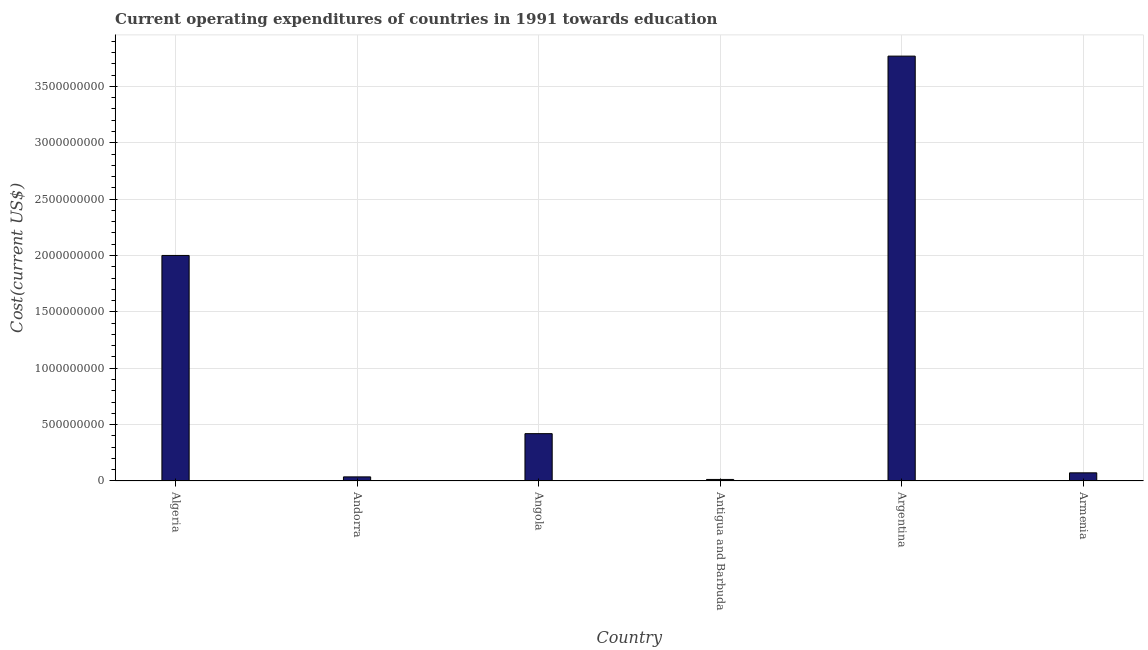What is the title of the graph?
Your answer should be very brief. Current operating expenditures of countries in 1991 towards education. What is the label or title of the Y-axis?
Ensure brevity in your answer.  Cost(current US$). What is the education expenditure in Antigua and Barbuda?
Give a very brief answer. 1.37e+07. Across all countries, what is the maximum education expenditure?
Make the answer very short. 3.77e+09. Across all countries, what is the minimum education expenditure?
Your answer should be very brief. 1.37e+07. In which country was the education expenditure minimum?
Keep it short and to the point. Antigua and Barbuda. What is the sum of the education expenditure?
Offer a very short reply. 6.31e+09. What is the difference between the education expenditure in Algeria and Antigua and Barbuda?
Ensure brevity in your answer.  1.99e+09. What is the average education expenditure per country?
Your response must be concise. 1.05e+09. What is the median education expenditure?
Provide a short and direct response. 2.46e+08. What is the ratio of the education expenditure in Andorra to that in Armenia?
Keep it short and to the point. 0.51. What is the difference between the highest and the second highest education expenditure?
Make the answer very short. 1.77e+09. What is the difference between the highest and the lowest education expenditure?
Offer a very short reply. 3.76e+09. In how many countries, is the education expenditure greater than the average education expenditure taken over all countries?
Offer a very short reply. 2. How many bars are there?
Your answer should be compact. 6. What is the difference between two consecutive major ticks on the Y-axis?
Keep it short and to the point. 5.00e+08. Are the values on the major ticks of Y-axis written in scientific E-notation?
Provide a succinct answer. No. What is the Cost(current US$) of Algeria?
Provide a short and direct response. 2.00e+09. What is the Cost(current US$) in Andorra?
Provide a short and direct response. 3.65e+07. What is the Cost(current US$) of Angola?
Your answer should be very brief. 4.20e+08. What is the Cost(current US$) in Antigua and Barbuda?
Your answer should be very brief. 1.37e+07. What is the Cost(current US$) in Argentina?
Offer a terse response. 3.77e+09. What is the Cost(current US$) in Armenia?
Provide a short and direct response. 7.23e+07. What is the difference between the Cost(current US$) in Algeria and Andorra?
Provide a succinct answer. 1.96e+09. What is the difference between the Cost(current US$) in Algeria and Angola?
Ensure brevity in your answer.  1.58e+09. What is the difference between the Cost(current US$) in Algeria and Antigua and Barbuda?
Provide a succinct answer. 1.99e+09. What is the difference between the Cost(current US$) in Algeria and Argentina?
Offer a very short reply. -1.77e+09. What is the difference between the Cost(current US$) in Algeria and Armenia?
Offer a terse response. 1.93e+09. What is the difference between the Cost(current US$) in Andorra and Angola?
Your answer should be compact. -3.83e+08. What is the difference between the Cost(current US$) in Andorra and Antigua and Barbuda?
Give a very brief answer. 2.28e+07. What is the difference between the Cost(current US$) in Andorra and Argentina?
Your answer should be very brief. -3.73e+09. What is the difference between the Cost(current US$) in Andorra and Armenia?
Your answer should be compact. -3.58e+07. What is the difference between the Cost(current US$) in Angola and Antigua and Barbuda?
Keep it short and to the point. 4.06e+08. What is the difference between the Cost(current US$) in Angola and Argentina?
Offer a very short reply. -3.35e+09. What is the difference between the Cost(current US$) in Angola and Armenia?
Give a very brief answer. 3.48e+08. What is the difference between the Cost(current US$) in Antigua and Barbuda and Argentina?
Your answer should be very brief. -3.76e+09. What is the difference between the Cost(current US$) in Antigua and Barbuda and Armenia?
Keep it short and to the point. -5.86e+07. What is the difference between the Cost(current US$) in Argentina and Armenia?
Ensure brevity in your answer.  3.70e+09. What is the ratio of the Cost(current US$) in Algeria to that in Andorra?
Your answer should be compact. 54.77. What is the ratio of the Cost(current US$) in Algeria to that in Angola?
Provide a short and direct response. 4.76. What is the ratio of the Cost(current US$) in Algeria to that in Antigua and Barbuda?
Your answer should be compact. 146.26. What is the ratio of the Cost(current US$) in Algeria to that in Argentina?
Offer a very short reply. 0.53. What is the ratio of the Cost(current US$) in Algeria to that in Armenia?
Keep it short and to the point. 27.67. What is the ratio of the Cost(current US$) in Andorra to that in Angola?
Ensure brevity in your answer.  0.09. What is the ratio of the Cost(current US$) in Andorra to that in Antigua and Barbuda?
Your answer should be compact. 2.67. What is the ratio of the Cost(current US$) in Andorra to that in Argentina?
Provide a short and direct response. 0.01. What is the ratio of the Cost(current US$) in Andorra to that in Armenia?
Provide a succinct answer. 0.51. What is the ratio of the Cost(current US$) in Angola to that in Antigua and Barbuda?
Give a very brief answer. 30.7. What is the ratio of the Cost(current US$) in Angola to that in Argentina?
Your response must be concise. 0.11. What is the ratio of the Cost(current US$) in Angola to that in Armenia?
Ensure brevity in your answer.  5.81. What is the ratio of the Cost(current US$) in Antigua and Barbuda to that in Argentina?
Provide a short and direct response. 0. What is the ratio of the Cost(current US$) in Antigua and Barbuda to that in Armenia?
Offer a terse response. 0.19. What is the ratio of the Cost(current US$) in Argentina to that in Armenia?
Give a very brief answer. 52.12. 